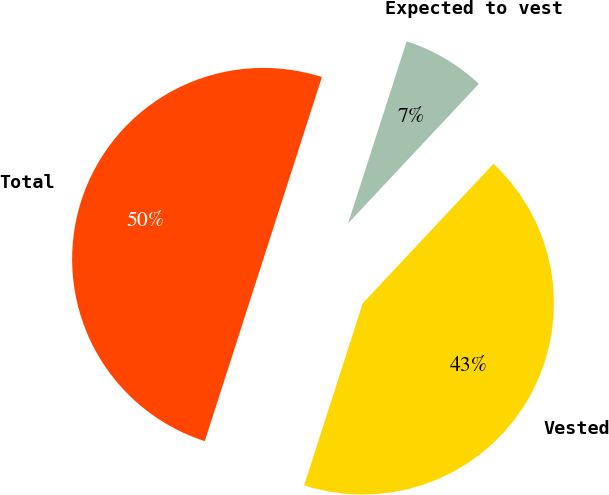Convert chart to OTSL. <chart><loc_0><loc_0><loc_500><loc_500><pie_chart><fcel>Vested<fcel>Expected to vest<fcel>Total<nl><fcel>42.97%<fcel>7.03%<fcel>50.0%<nl></chart> 